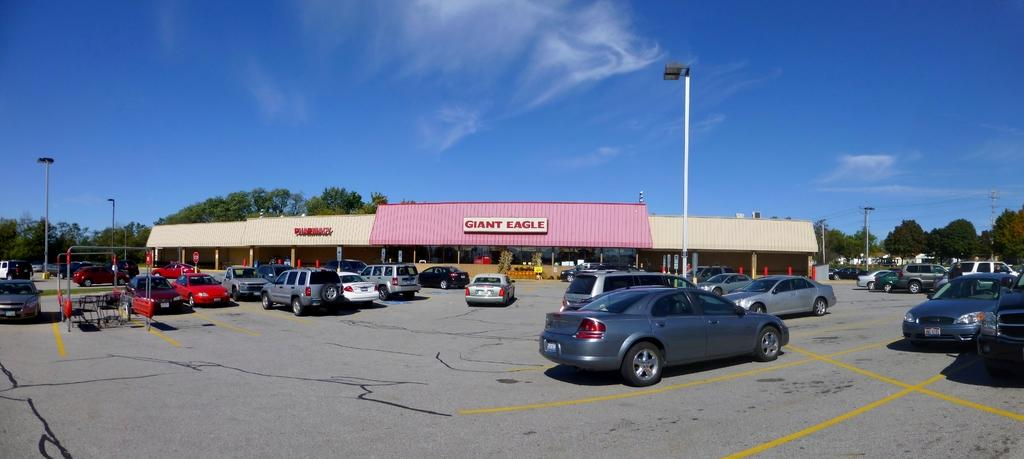What type of vehicles can be seen in the image? There are cars in the image. What type of furniture is present in the image? There are chairs in the image. What type of structures can be seen in the image? There are poles and a shed in the image. What type of vegetation is present in the image? There are trees in the image. What type of flat surfaces are present in the image? There are boards in the image. What is visible in the background of the image? The sky is visible in the background of the image. What type of straw is being used to keep the shed warm in the image? There is no straw present in the image, nor is there any indication that the shed needs to be kept warm. 